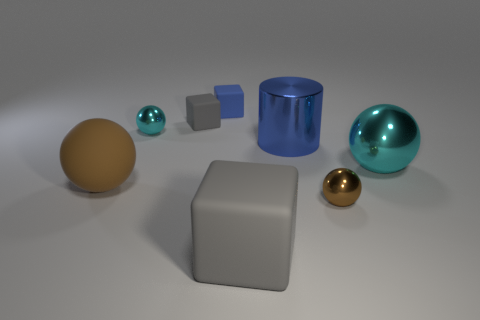There is a object that is the same color as the rubber sphere; what material is it?
Offer a terse response. Metal. There is a big object to the left of the cyan sphere that is behind the shiny sphere right of the tiny brown metal thing; what is its color?
Your response must be concise. Brown. Is the number of large cyan metallic balls that are behind the tiny gray matte thing the same as the number of blue matte objects?
Ensure brevity in your answer.  No. There is a brown ball that is on the right side of the shiny cylinder; is its size the same as the large brown ball?
Offer a terse response. No. What number of tiny matte objects are there?
Provide a short and direct response. 2. How many spheres are both in front of the small cyan ball and on the left side of the big cyan object?
Offer a very short reply. 2. Are there any small blocks made of the same material as the tiny cyan sphere?
Ensure brevity in your answer.  No. What is the material of the brown object right of the block on the left side of the blue matte thing?
Your response must be concise. Metal. Are there the same number of big gray rubber blocks right of the large rubber sphere and cylinders that are on the right side of the big blue metallic cylinder?
Your response must be concise. No. Does the big cyan shiny thing have the same shape as the large gray rubber object?
Keep it short and to the point. No. 